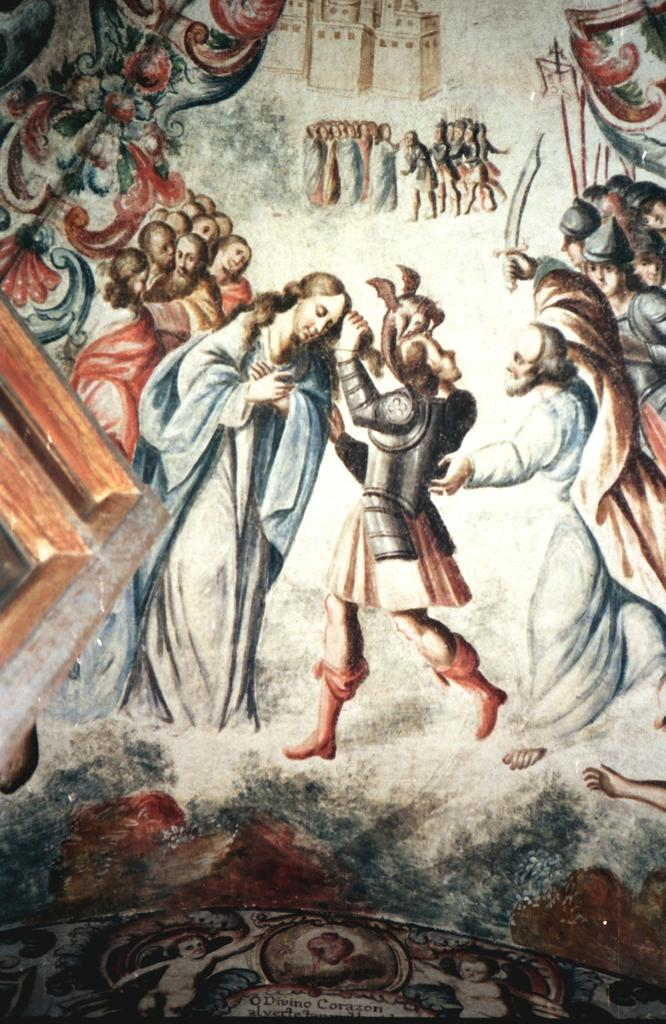What subjects are depicted in the image? There is a picture of people and a building in the image. Can you describe the people in the image? The provided facts do not give specific details about the people in the image. What type of building is shown in the image? The provided facts do not give specific details about the building in the image. What type of recess is visible in the image? There is no recess present in the image. Who is the owner of the building in the image? The provided facts do not give any information about the ownership of the building in the image. 